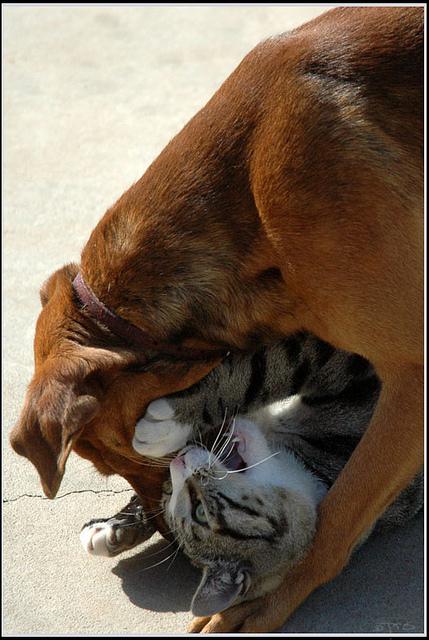Do these two like each other?
Keep it brief. Yes. Are these animals of the same species?
Concise answer only. No. How many of these animals have paws?
Write a very short answer. 2. 